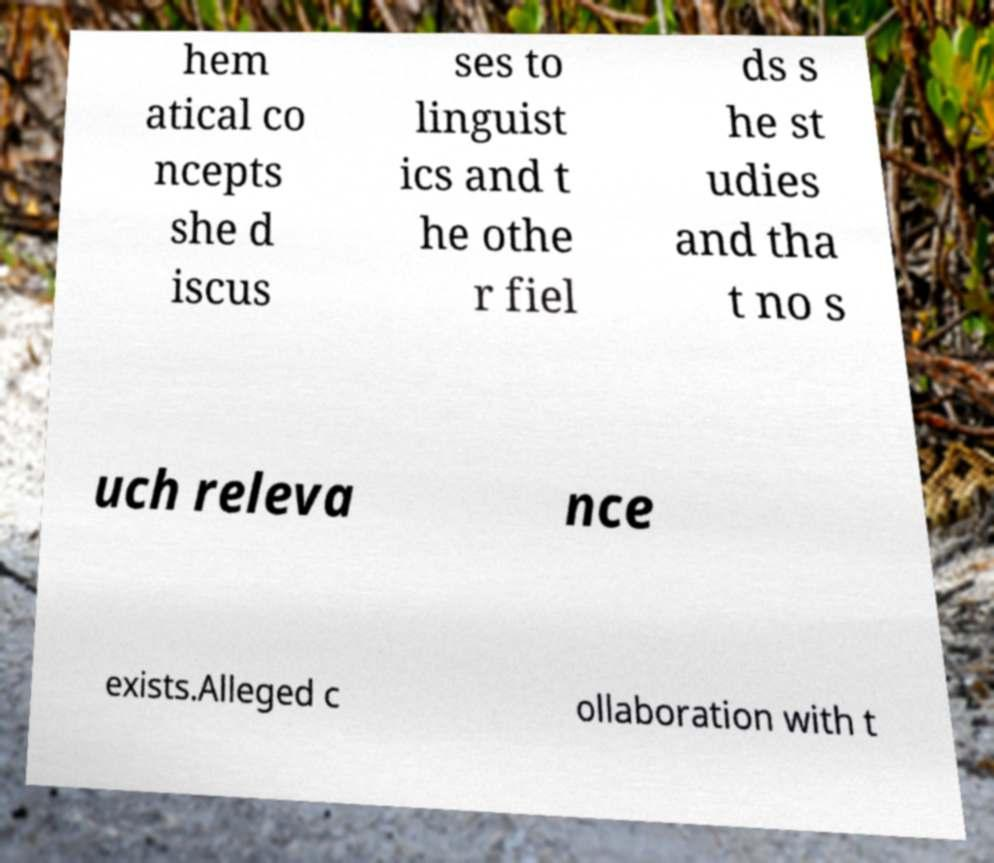There's text embedded in this image that I need extracted. Can you transcribe it verbatim? hem atical co ncepts she d iscus ses to linguist ics and t he othe r fiel ds s he st udies and tha t no s uch releva nce exists.Alleged c ollaboration with t 